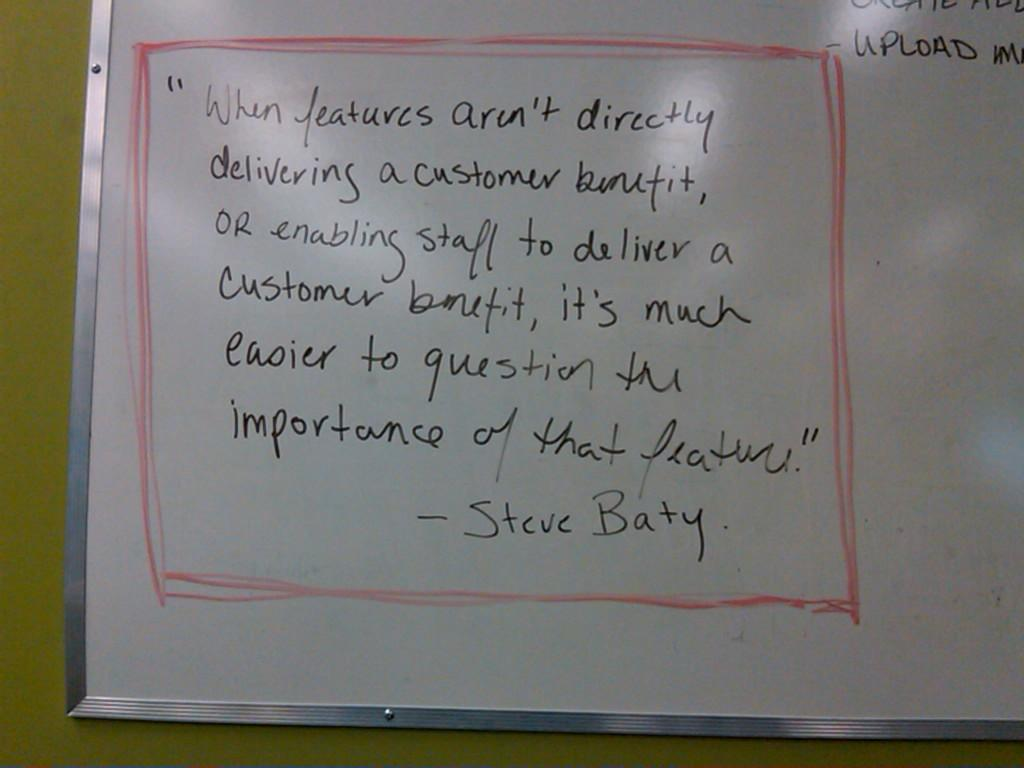<image>
Write a terse but informative summary of the picture. A white board has a quote by Steve Baty written on it 